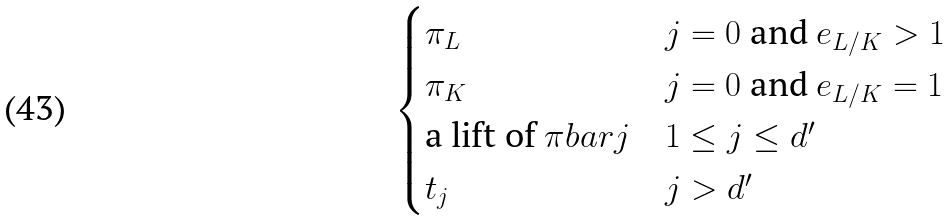Convert formula to latex. <formula><loc_0><loc_0><loc_500><loc_500>\begin{cases} \pi _ { L } & j = 0 \ \text {and} \ e _ { L / K } > 1 \\ \pi _ { K } & j = 0 \ \text {and} \ e _ { L / K } = 1 \\ \text {a lift of} \ \pi b a r { j } & 1 \leq j \leq d ^ { \prime } \\ t _ { j } & j > d ^ { \prime } \end{cases}</formula> 